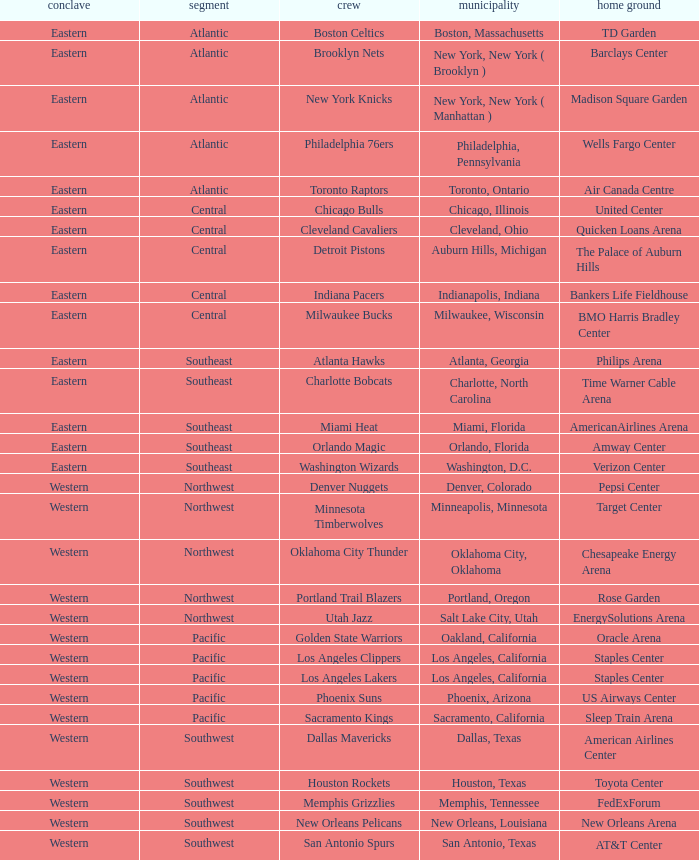Which city includes the Target Center arena? Minneapolis, Minnesota. 